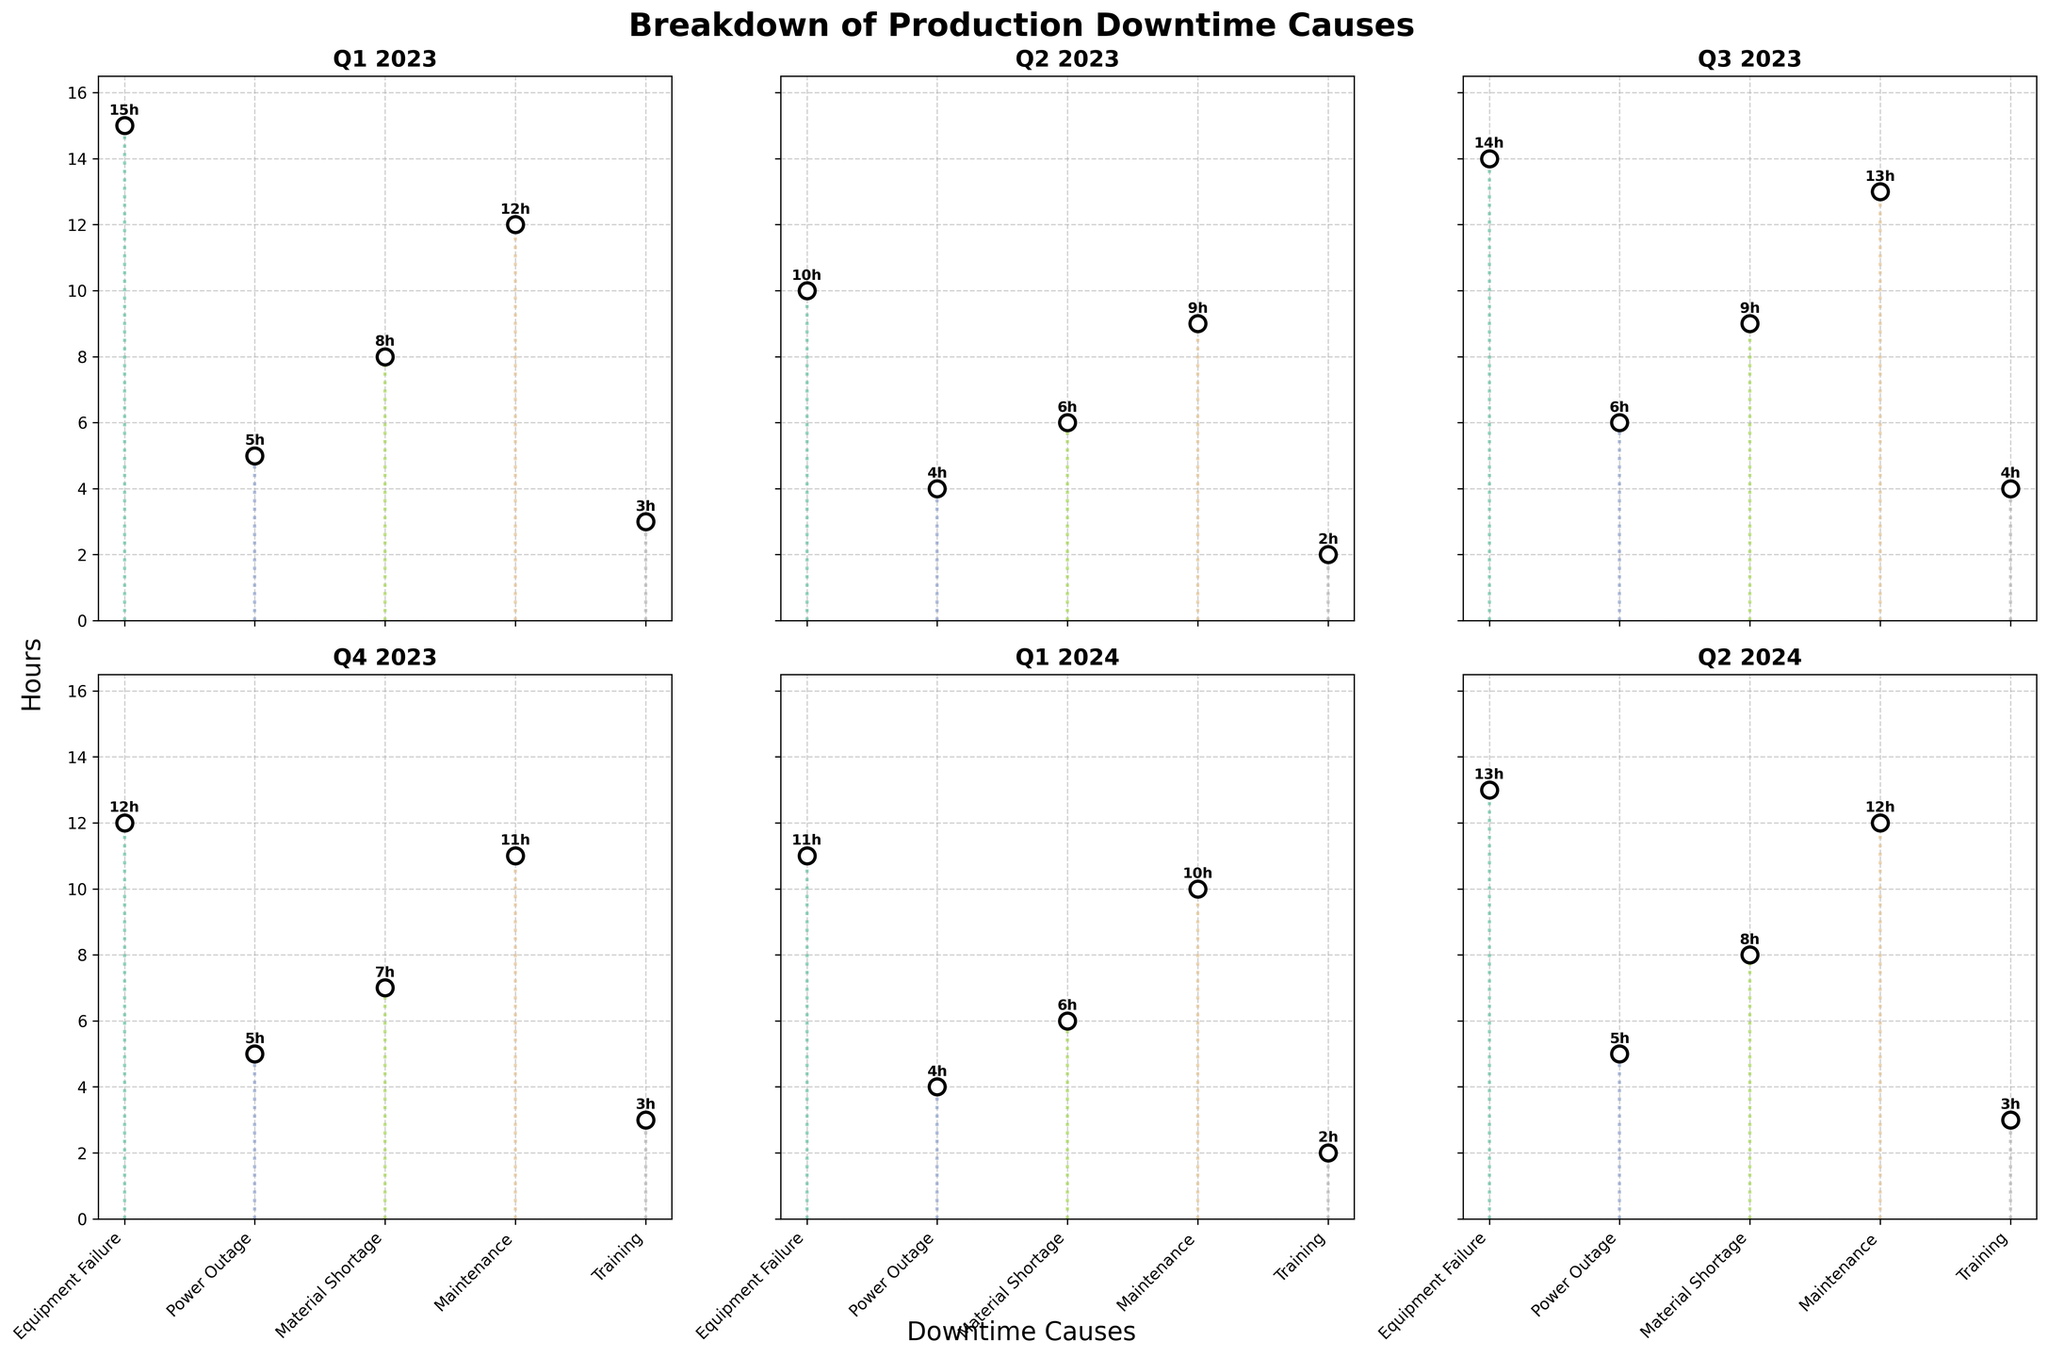What is the total number of hours lost due to Equipment Failure across all periods? To find the total hours lost due to Equipment Failure, sum up the corresponding values from each period: 15 (Q1 2023) + 10 (Q2 2023) + 14 (Q3 2023) + 12 (Q4 2023) + 11 (Q1 2024) + 13 (Q2 2024). This results in a total of 75 hours.
Answer: 75 hours Which period had the highest total downtime hours? First, find the sum of downtime hours for each period: Q1 2023 (15+5+8+12+3 = 43), Q2 2023 (10+4+6+9+2 = 31), Q3 2023 (14+6+9+13+4 = 46), Q4 2023 (12+5+7+11+3 = 38), Q1 2024 (11+4+6+10+2 = 33), Q2 2024 (13+5+8+12+3 = 41). Q3 2023 has the highest total with 46 hours.
Answer: Q3 2023 What is the average downtime due to Maintenance across all periods? To find the average downtime for Maintenance, sum up the corresponding hours from each period and divide by the number of periods: (12+9+13+11+10+12) which equals 67. Then, divide 67 by 6 (number of periods), resulting in an average of approximately 11.17 hours.
Answer: Approximately 11.17 hours Which cause had the least downtime in Q1 2023? Observing the Q1 2023 subplot, the breakdown of downtime is as follows: Equipment Failure (15 hours), Power Outage (5 hours), Material Shortage (8 hours), Maintenance (12 hours), and Training (3 hours). Training had the least downtime at 3 hours.
Answer: Training How does the downtime due to Material Shortage in Q3 2023 compare to Q2 2024? In Q3 2023, Material Shortage accounts for 9 hours, while in Q2 2024, it accounts for 8 hours. By comparing these values, we see that Q3 2023 has 1 more hour of downtime than Q2 2024 for Material Shortage.
Answer: Q3 2023 has 1 more hour Did Equipment Failure downtime increase or decrease from Q1 2023 to Q4 2023? Equipment Failure downtime in Q1 2023 was 15 hours and in Q4 2023, it was 12 hours. Since 12 is less than 15, the downtime decreased.
Answer: Decrease Which downtime cause had the most consistent hours across the periods? For each cause, observe the variation in hours across all periods:
- Equipment Failure: 15, 10, 14, 12, 11, 13 (range 10 to 15)
- Power Outage: 5, 4, 6, 5, 4, 5 (range 4 to 6)
- Material Shortage: 8, 6, 9, 7, 6, 8 (range 6 to 9)
- Maintenance: 12, 9, 13, 11, 10, 12 (range 9 to 13)
- Training: 3, 2, 4, 3, 2, 3 (range 2 to 4)
Power Outage has the smallest range of hours (4 to 6), indicating the most consistent downtime.
Answer: Power Outage How many total periods are represented in the subplots? Each column in the subplot represents one period. There are 6 columns in total, so there are 6 periods represented. They are: Q1 2023, Q2 2023, Q3 2023, Q4 2023, Q1 2024, and Q2 2024.
Answer: 6 What is the maximum downtime hour observed in any cause across any period? By scanning through all subplots, the maximum downtime observed is Equipment Failure in Q1 2023, which is 15 hours.
Answer: 15 hours 